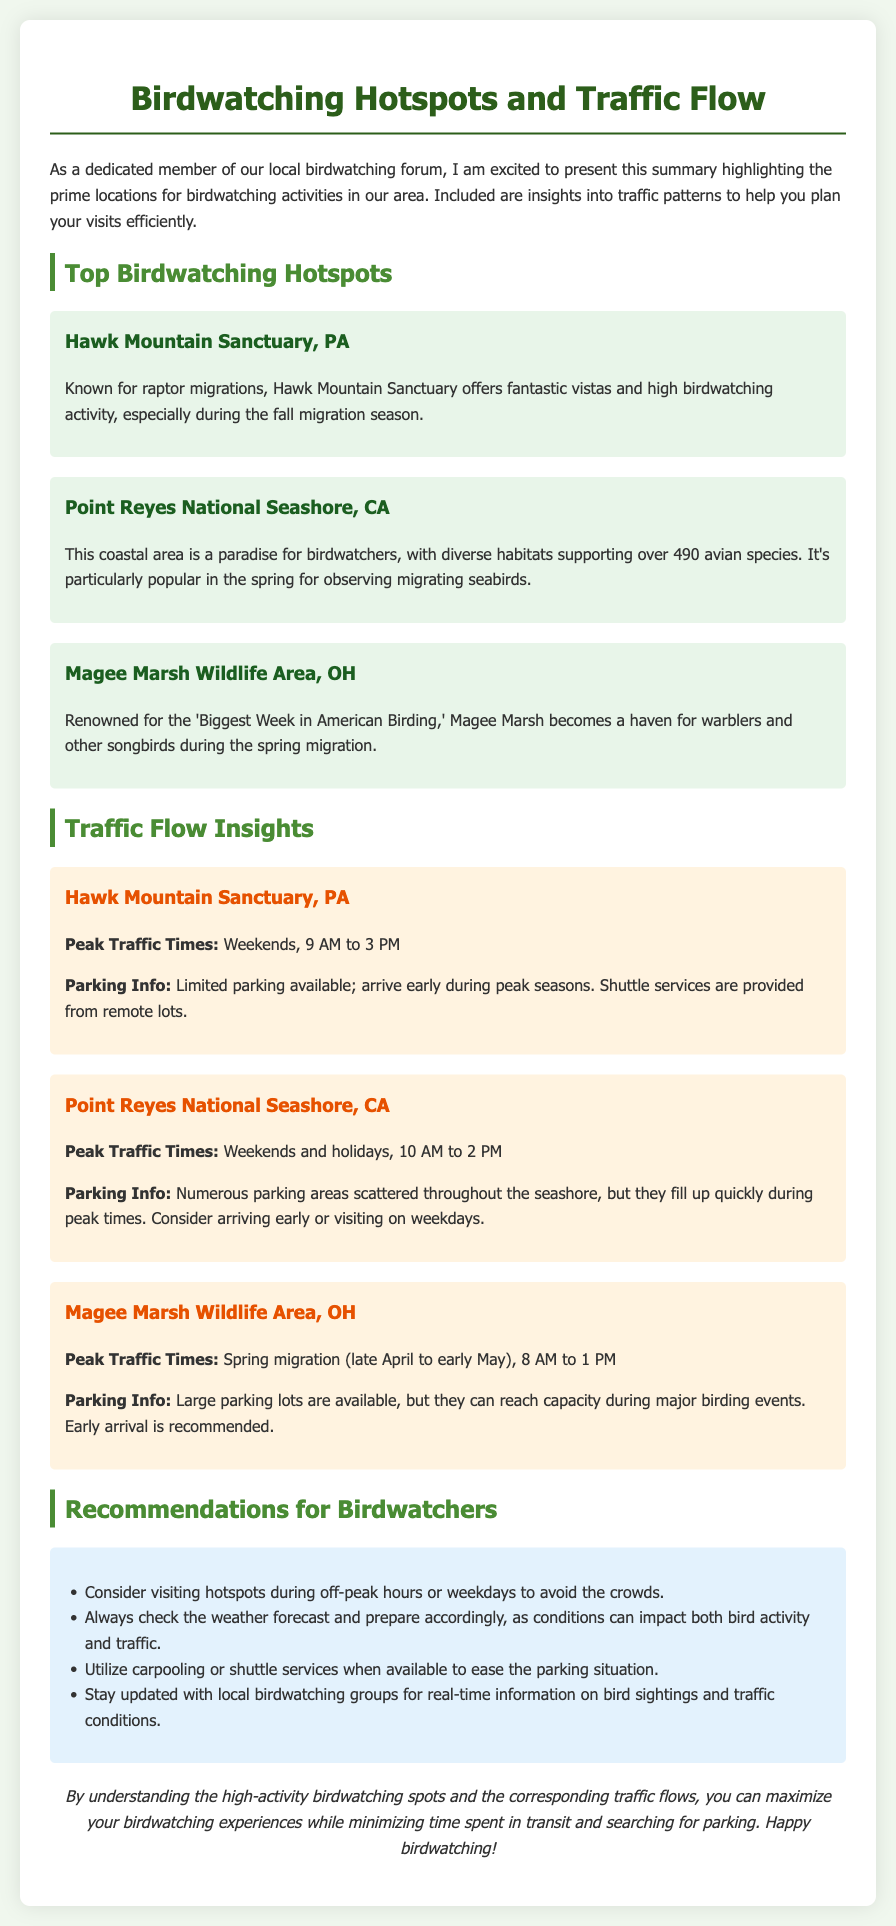What is the first hotspot listed? The first hotspot mentioned in the document is Hawk Mountain Sanctuary, PA.
Answer: Hawk Mountain Sanctuary, PA What is the peak traffic time for Point Reyes National Seashore? The peak traffic time for Point Reyes National Seashore is on weekends and holidays from 10 AM to 2 PM.
Answer: Weekends and holidays, 10 AM to 2 PM How many avian species are supported by Point Reyes National Seashore? The document states that Point Reyes National Seashore supports over 490 avian species.
Answer: Over 490 What should birdwatchers do to avoid crowds? Birdwatchers are advised to visit hotspots during off-peak hours or weekdays to avoid the crowds.
Answer: Visit during off-peak hours or weekdays What is the parking situation at Magee Marsh Wildlife Area? Magee Marsh Wildlife Area has large parking lots available, but they can reach capacity during major birding events.
Answer: Large parking lots, may reach capacity What is the main focus of the document? The main focus of the document is to summarize birdwatching hotspots and corresponding traffic flow insights.
Answer: Birdwatching hotspots and traffic flow insights What is the primary recommendation regarding shuttle services? The recommendation is to utilize carpooling or shuttle services when available to ease the parking situation.
Answer: Utilize carpooling or shuttle services When is the best time to visit Magee Marsh Wildlife Area? The best time to visit Magee Marsh Wildlife Area is during the spring migration, particularly late April to early May.
Answer: Spring migration (late April to early May) 